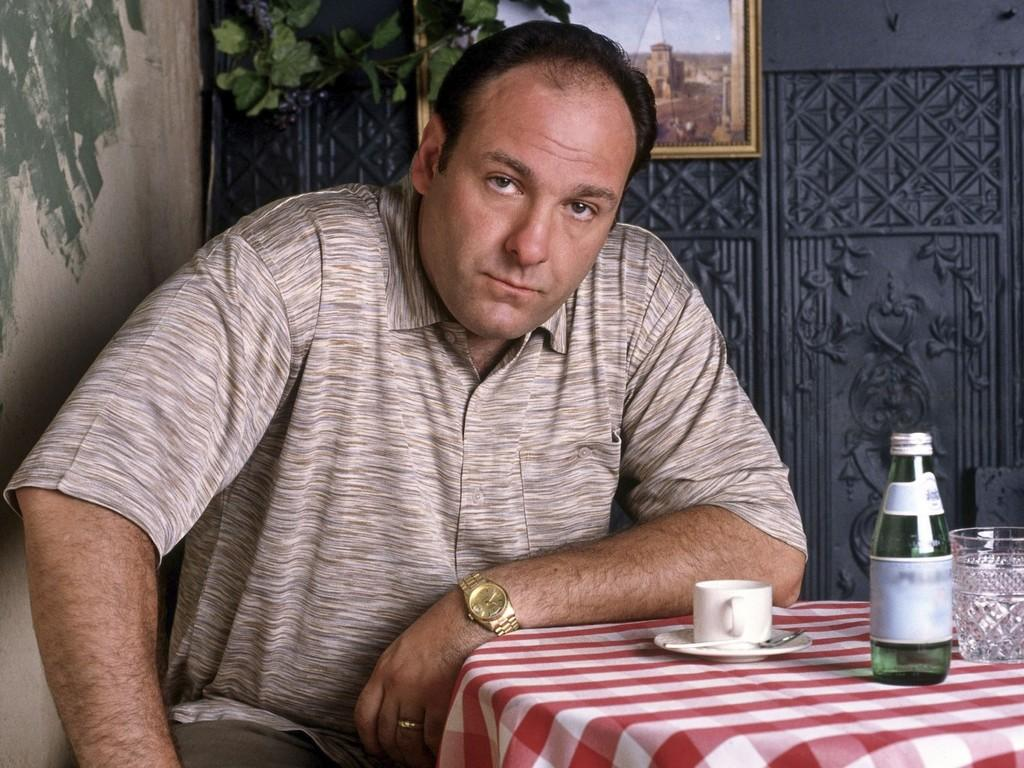What is the man in the image doing? The man is sitting in a chair. What is near the man in the image? The man is near a table. What items can be seen on the table? There is a cup, a spoon, a saucer, and a glass on the table. What can be seen in the background of the image? There is a wall, a plant, and a frame in the background. What type of stone is the man using as a seat in the image? There is no stone present in the image; the man is sitting in a chair. What holiday is being celebrated in the image? There is no indication of a holiday being celebrated in the image. 